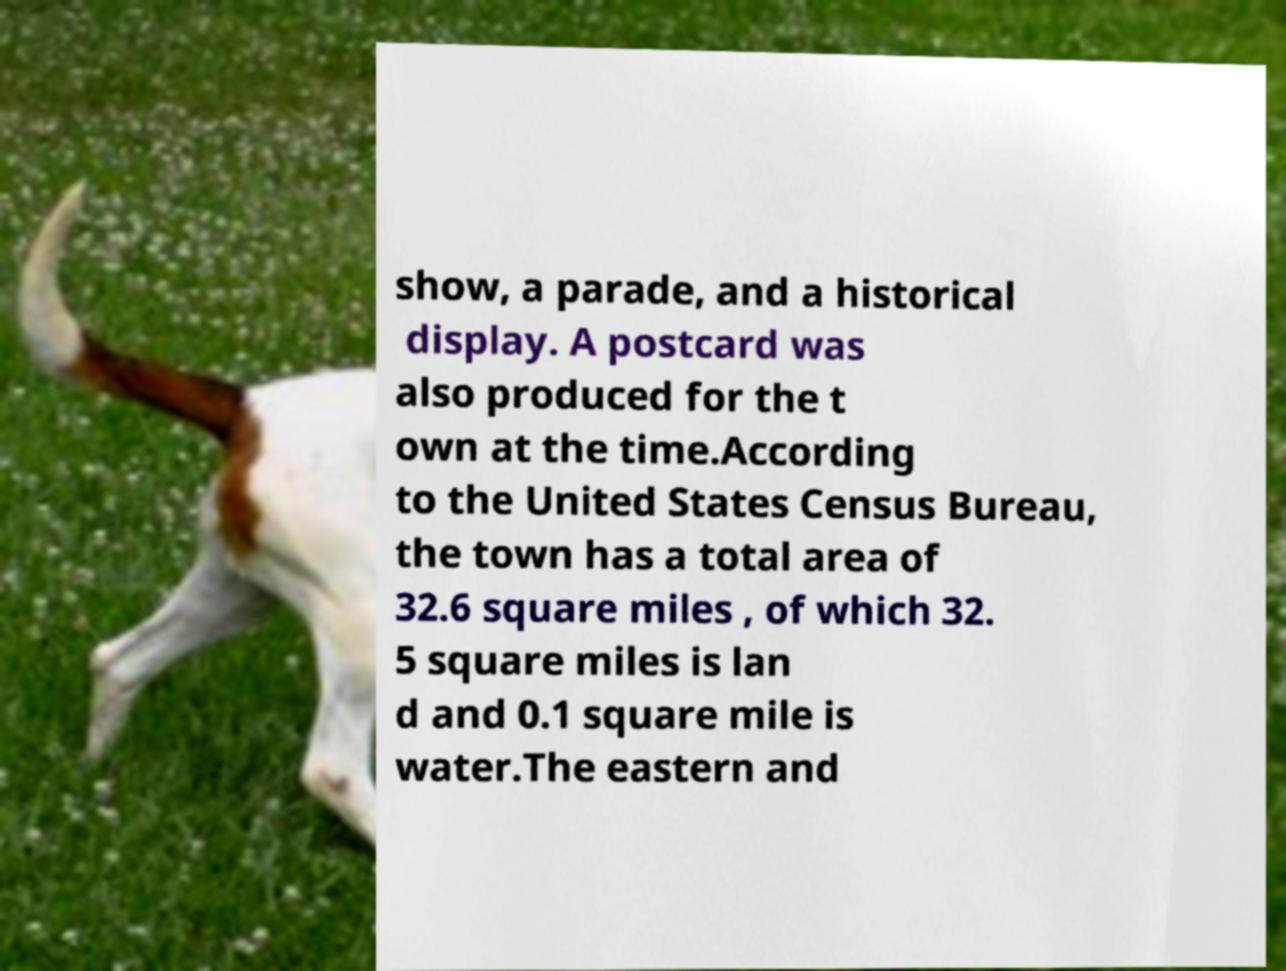Please read and relay the text visible in this image. What does it say? show, a parade, and a historical display. A postcard was also produced for the t own at the time.According to the United States Census Bureau, the town has a total area of 32.6 square miles , of which 32. 5 square miles is lan d and 0.1 square mile is water.The eastern and 